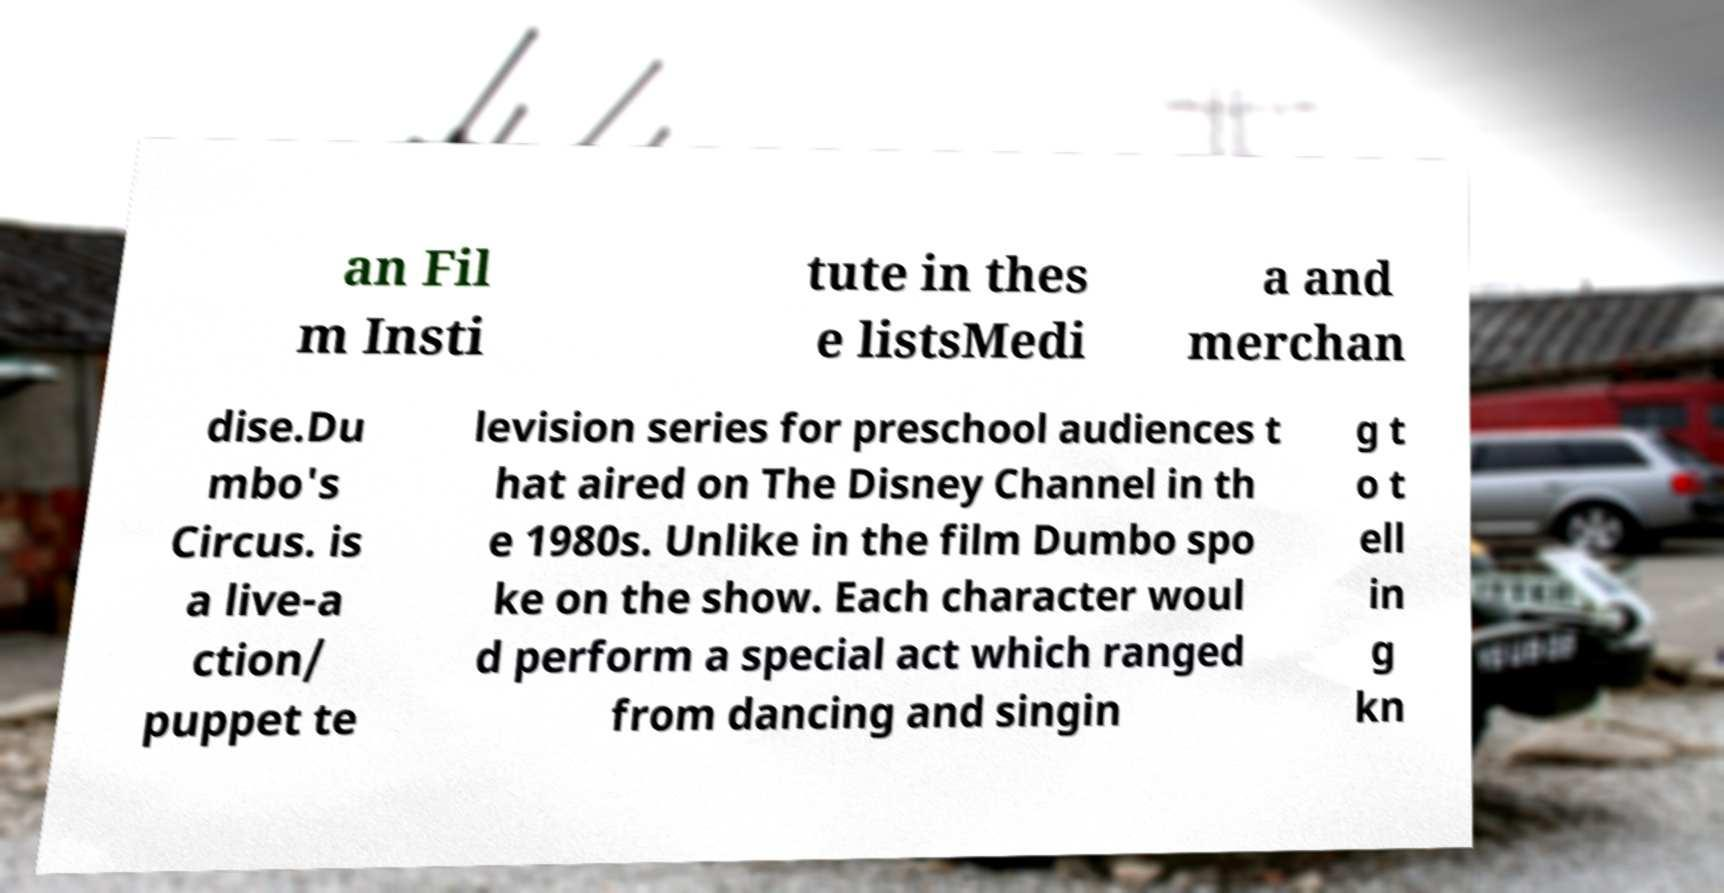Could you assist in decoding the text presented in this image and type it out clearly? an Fil m Insti tute in thes e listsMedi a and merchan dise.Du mbo's Circus. is a live-a ction/ puppet te levision series for preschool audiences t hat aired on The Disney Channel in th e 1980s. Unlike in the film Dumbo spo ke on the show. Each character woul d perform a special act which ranged from dancing and singin g t o t ell in g kn 